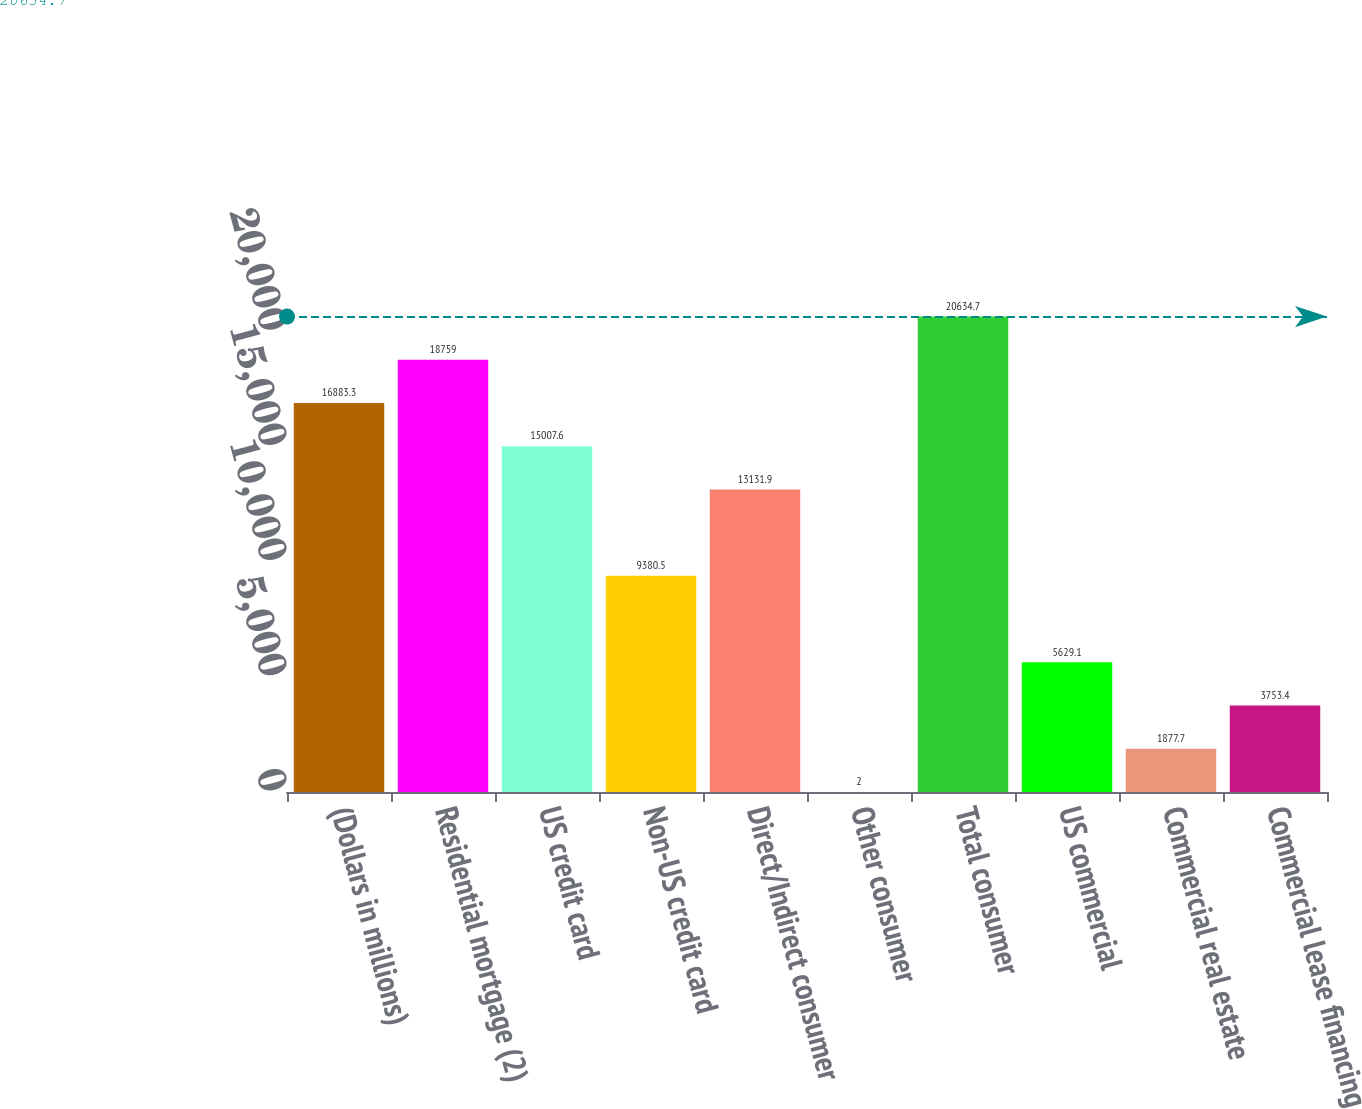Convert chart. <chart><loc_0><loc_0><loc_500><loc_500><bar_chart><fcel>(Dollars in millions)<fcel>Residential mortgage (2)<fcel>US credit card<fcel>Non-US credit card<fcel>Direct/Indirect consumer<fcel>Other consumer<fcel>Total consumer<fcel>US commercial<fcel>Commercial real estate<fcel>Commercial lease financing<nl><fcel>16883.3<fcel>18759<fcel>15007.6<fcel>9380.5<fcel>13131.9<fcel>2<fcel>20634.7<fcel>5629.1<fcel>1877.7<fcel>3753.4<nl></chart> 